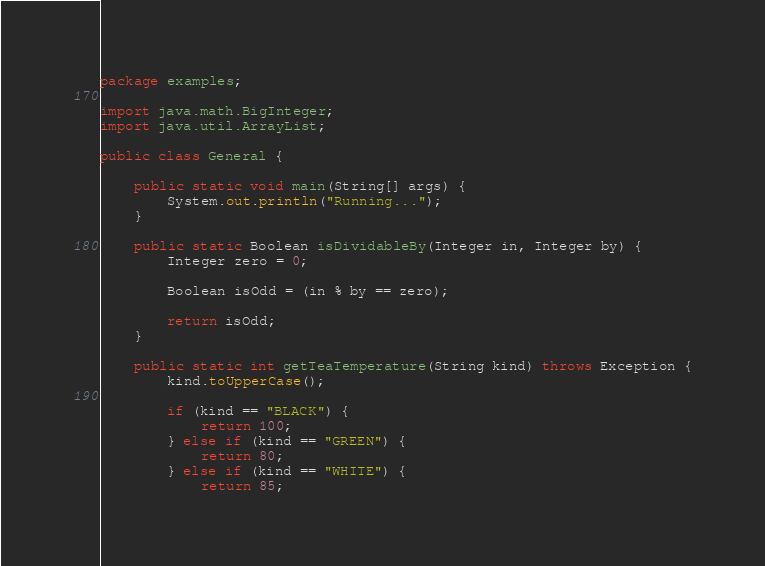Convert code to text. <code><loc_0><loc_0><loc_500><loc_500><_Java_>package examples;

import java.math.BigInteger;
import java.util.ArrayList;

public class General {

	public static void main(String[] args) {
		System.out.println("Running...");
	}

	public static Boolean isDividableBy(Integer in, Integer by) {
		Integer zero = 0;

		Boolean isOdd = (in % by == zero);

		return isOdd;
	}

	public static int getTeaTemperature(String kind) throws Exception {
		kind.toUpperCase();

		if (kind == "BLACK") {
			return 100;
		} else if (kind == "GREEN") {
			return 80;
		} else if (kind == "WHITE") {
			return 85;</code> 